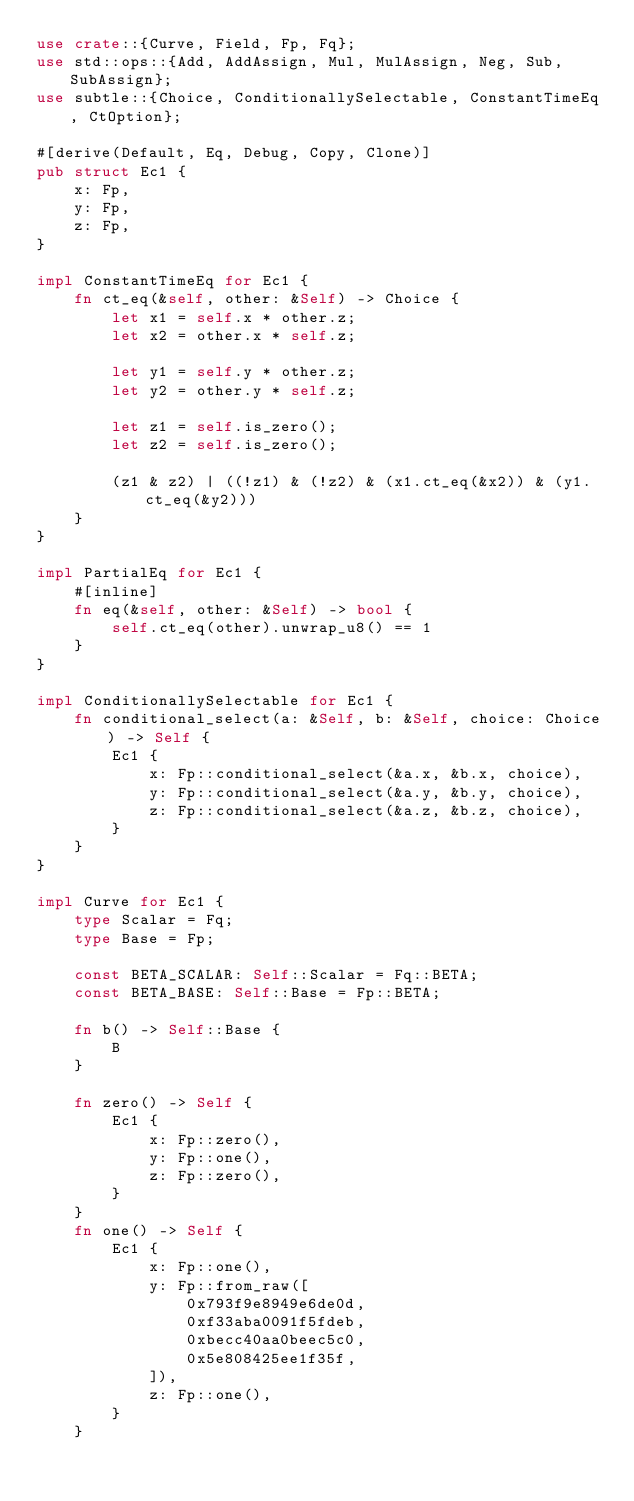Convert code to text. <code><loc_0><loc_0><loc_500><loc_500><_Rust_>use crate::{Curve, Field, Fp, Fq};
use std::ops::{Add, AddAssign, Mul, MulAssign, Neg, Sub, SubAssign};
use subtle::{Choice, ConditionallySelectable, ConstantTimeEq, CtOption};

#[derive(Default, Eq, Debug, Copy, Clone)]
pub struct Ec1 {
    x: Fp,
    y: Fp,
    z: Fp,
}

impl ConstantTimeEq for Ec1 {
    fn ct_eq(&self, other: &Self) -> Choice {
        let x1 = self.x * other.z;
        let x2 = other.x * self.z;

        let y1 = self.y * other.z;
        let y2 = other.y * self.z;

        let z1 = self.is_zero();
        let z2 = self.is_zero();

        (z1 & z2) | ((!z1) & (!z2) & (x1.ct_eq(&x2)) & (y1.ct_eq(&y2)))
    }
}

impl PartialEq for Ec1 {
    #[inline]
    fn eq(&self, other: &Self) -> bool {
        self.ct_eq(other).unwrap_u8() == 1
    }
}

impl ConditionallySelectable for Ec1 {
    fn conditional_select(a: &Self, b: &Self, choice: Choice) -> Self {
        Ec1 {
            x: Fp::conditional_select(&a.x, &b.x, choice),
            y: Fp::conditional_select(&a.y, &b.y, choice),
            z: Fp::conditional_select(&a.z, &b.z, choice),
        }
    }
}

impl Curve for Ec1 {
    type Scalar = Fq;
    type Base = Fp;

    const BETA_SCALAR: Self::Scalar = Fq::BETA;
    const BETA_BASE: Self::Base = Fp::BETA;

    fn b() -> Self::Base {
        B
    }

    fn zero() -> Self {
        Ec1 {
            x: Fp::zero(),
            y: Fp::one(),
            z: Fp::zero(),
        }
    }
    fn one() -> Self {
        Ec1 {
            x: Fp::one(),
            y: Fp::from_raw([
                0x793f9e8949e6de0d,
                0xf33aba0091f5fdeb,
                0xbecc40aa0beec5c0,
                0x5e808425ee1f35f,
            ]),
            z: Fp::one(),
        }
    }
</code> 